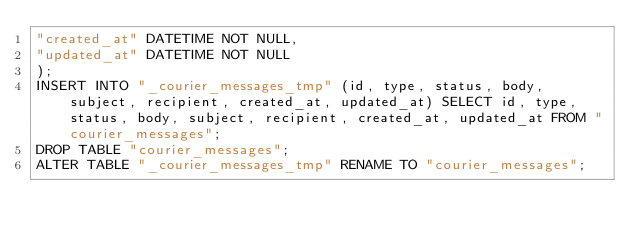Convert code to text. <code><loc_0><loc_0><loc_500><loc_500><_SQL_>"created_at" DATETIME NOT NULL,
"updated_at" DATETIME NOT NULL
);
INSERT INTO "_courier_messages_tmp" (id, type, status, body, subject, recipient, created_at, updated_at) SELECT id, type, status, body, subject, recipient, created_at, updated_at FROM "courier_messages";
DROP TABLE "courier_messages";
ALTER TABLE "_courier_messages_tmp" RENAME TO "courier_messages";</code> 